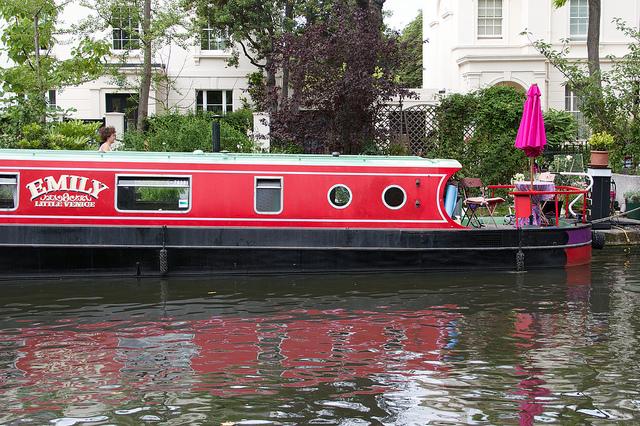How can you tell this is a reflection?
Quick response, please. It's shiny. How many windows can you see on the boat?
Write a very short answer. 5. Is there a beer ad?
Keep it brief. No. Does the water look clear?
Write a very short answer. No. Is this ship named for a boy or a girl?
Quick response, please. Girl. 